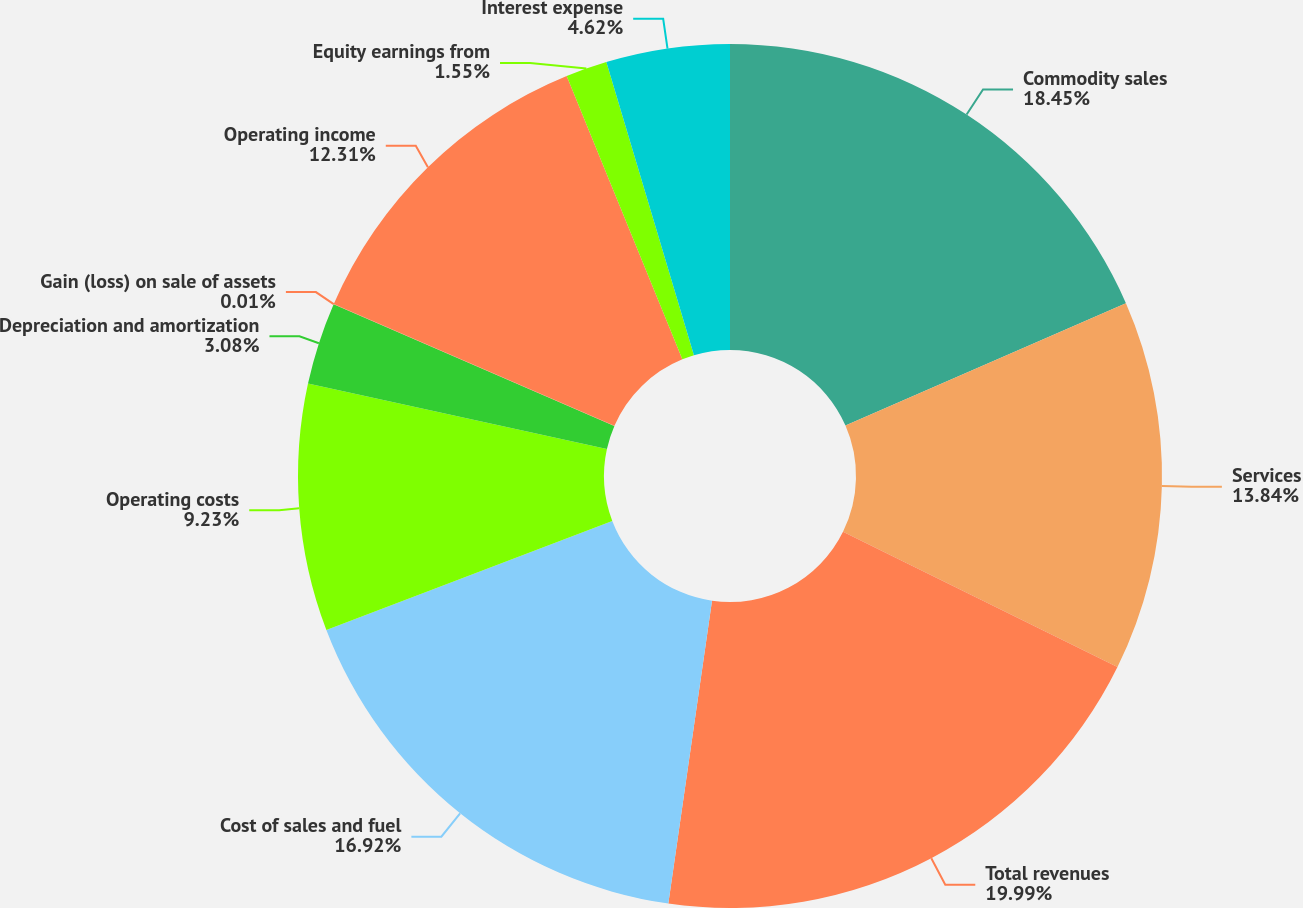<chart> <loc_0><loc_0><loc_500><loc_500><pie_chart><fcel>Commodity sales<fcel>Services<fcel>Total revenues<fcel>Cost of sales and fuel<fcel>Operating costs<fcel>Depreciation and amortization<fcel>Gain (loss) on sale of assets<fcel>Operating income<fcel>Equity earnings from<fcel>Interest expense<nl><fcel>18.45%<fcel>13.84%<fcel>19.99%<fcel>16.92%<fcel>9.23%<fcel>3.08%<fcel>0.01%<fcel>12.31%<fcel>1.55%<fcel>4.62%<nl></chart> 